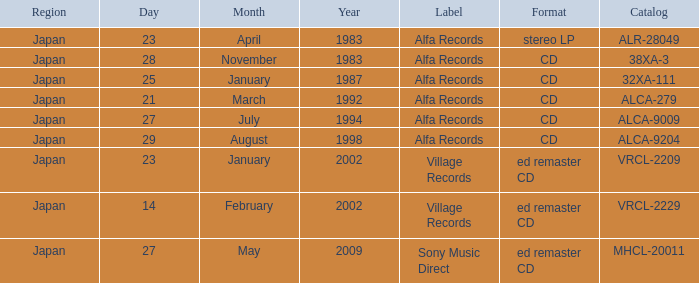Which date is in stereo lp format? April 23, 1983. 